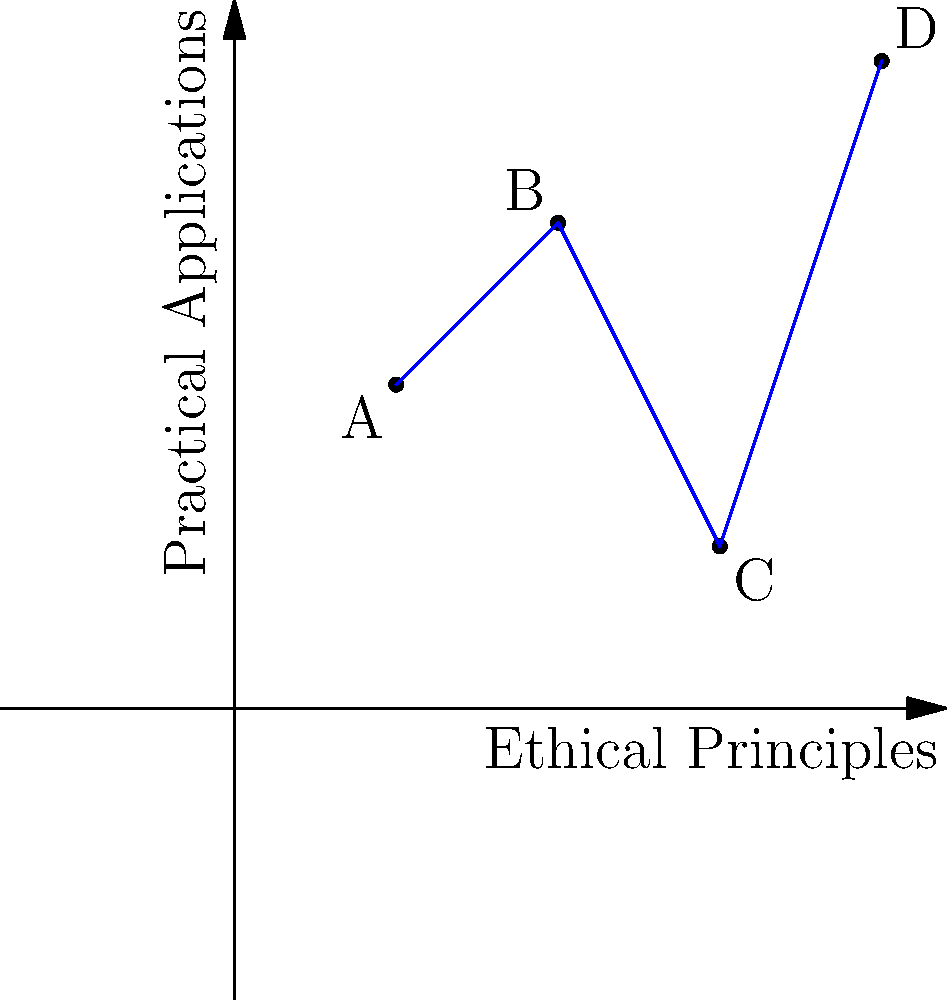In the context of ethical principles and their practical applications in society, consider the graph where the x-axis represents the strength of ethical principles and the y-axis represents the effectiveness of their practical applications. Points A(1,2), B(2,3), C(3,1), and D(4,4) represent different ethical frameworks. Calculate the dot product of vectors $\vec{AB}$ and $\vec{CD}$. What does this result suggest about the relationship between these ethical frameworks in terms of their principles and applications? To solve this problem and interpret its philosophical implications, let's follow these steps:

1) First, we need to calculate the vectors $\vec{AB}$ and $\vec{CD}$:
   $\vec{AB} = B - A = (2,3) - (1,2) = (1,1)$
   $\vec{CD} = D - C = (4,4) - (3,1) = (1,3)$

2) The dot product of two vectors $\vec{a} = (a_1, a_2)$ and $\vec{b} = (b_1, b_2)$ is defined as:
   $\vec{a} \cdot \vec{b} = a_1b_1 + a_2b_2$

3) Calculating the dot product:
   $\vec{AB} \cdot \vec{CD} = (1)(1) + (1)(3) = 1 + 3 = 4$

4) Interpretation:
   - The positive dot product indicates that these vectors are pointing in generally the same direction.
   - In our ethical context, this suggests that the transition from framework A to B is somewhat aligned with the transition from C to D.
   - The magnitude (4) indicates a moderate degree of alignment.

5) Philosophical implications:
   - The alignment suggests that as we move from A to B and from C to D, there's a similar trend in how ethical principles relate to their practical applications.
   - This could imply that despite differences in the absolute positions of these ethical frameworks, there might be some underlying commonality in how they evolve or are implemented in practice.
   - However, the moderate magnitude suggests that while there's alignment, it's not perfect, indicating some divergence in how these frameworks operate or are applied.

6) Sociological considerations:
   - This alignment might suggest that different ethical frameworks, despite their distinct positions, may respond similarly to societal pressures or changes.
   - It could indicate a degree of convergence in how ethical principles are practically applied across different philosophical traditions.
Answer: Positive alignment with moderate convergence in ethical evolution and practical application. 